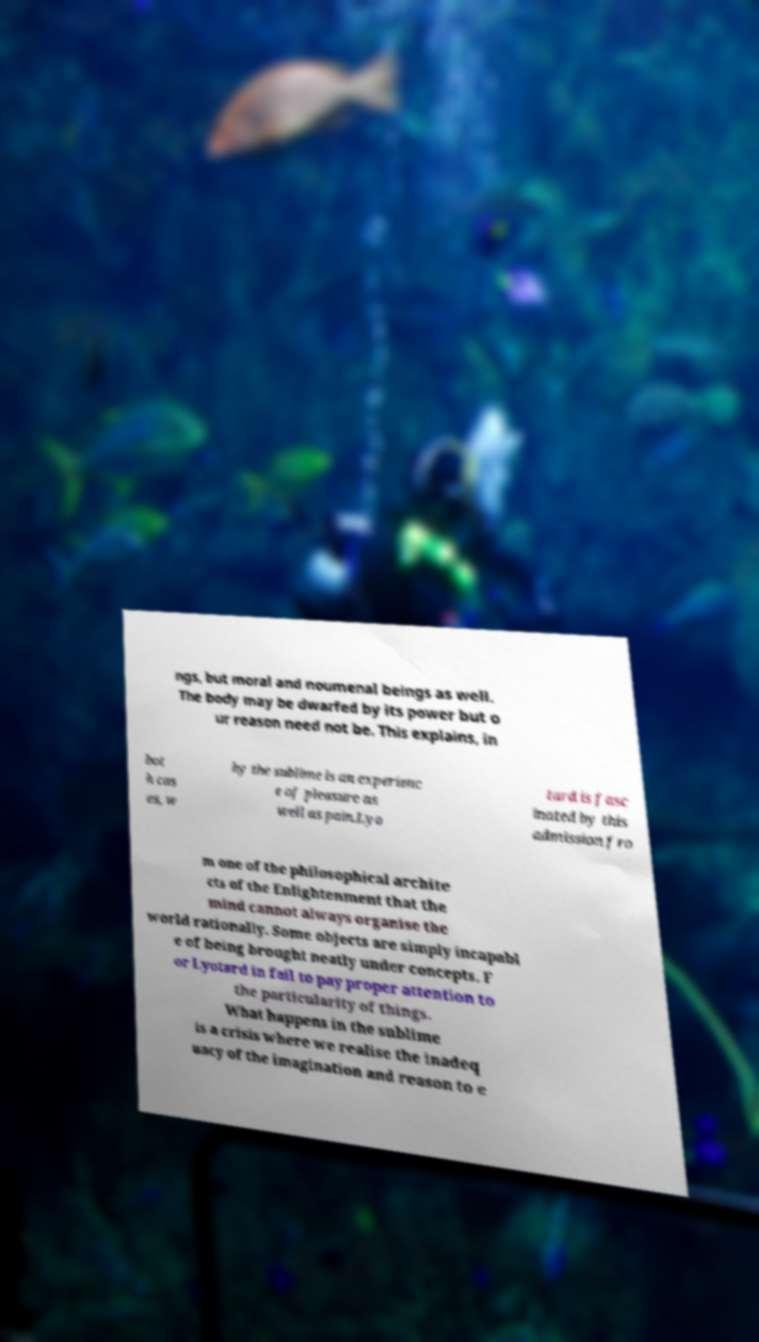Can you read and provide the text displayed in the image?This photo seems to have some interesting text. Can you extract and type it out for me? ngs, but moral and noumenal beings as well. The body may be dwarfed by its power but o ur reason need not be. This explains, in bot h cas es, w hy the sublime is an experienc e of pleasure as well as pain.Lyo tard is fasc inated by this admission fro m one of the philosophical archite cts of the Enlightenment that the mind cannot always organise the world rationally. Some objects are simply incapabl e of being brought neatly under concepts. F or Lyotard in fail to pay proper attention to the particularity of things. What happens in the sublime is a crisis where we realise the inadeq uacy of the imagination and reason to e 